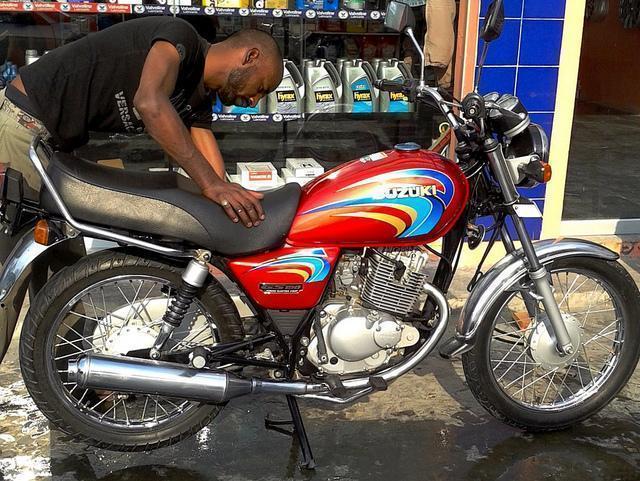What company makes the vehicle?
From the following four choices, select the correct answer to address the question.
Options: Ford, suzuki, tesla, general motors. Suzuki. 